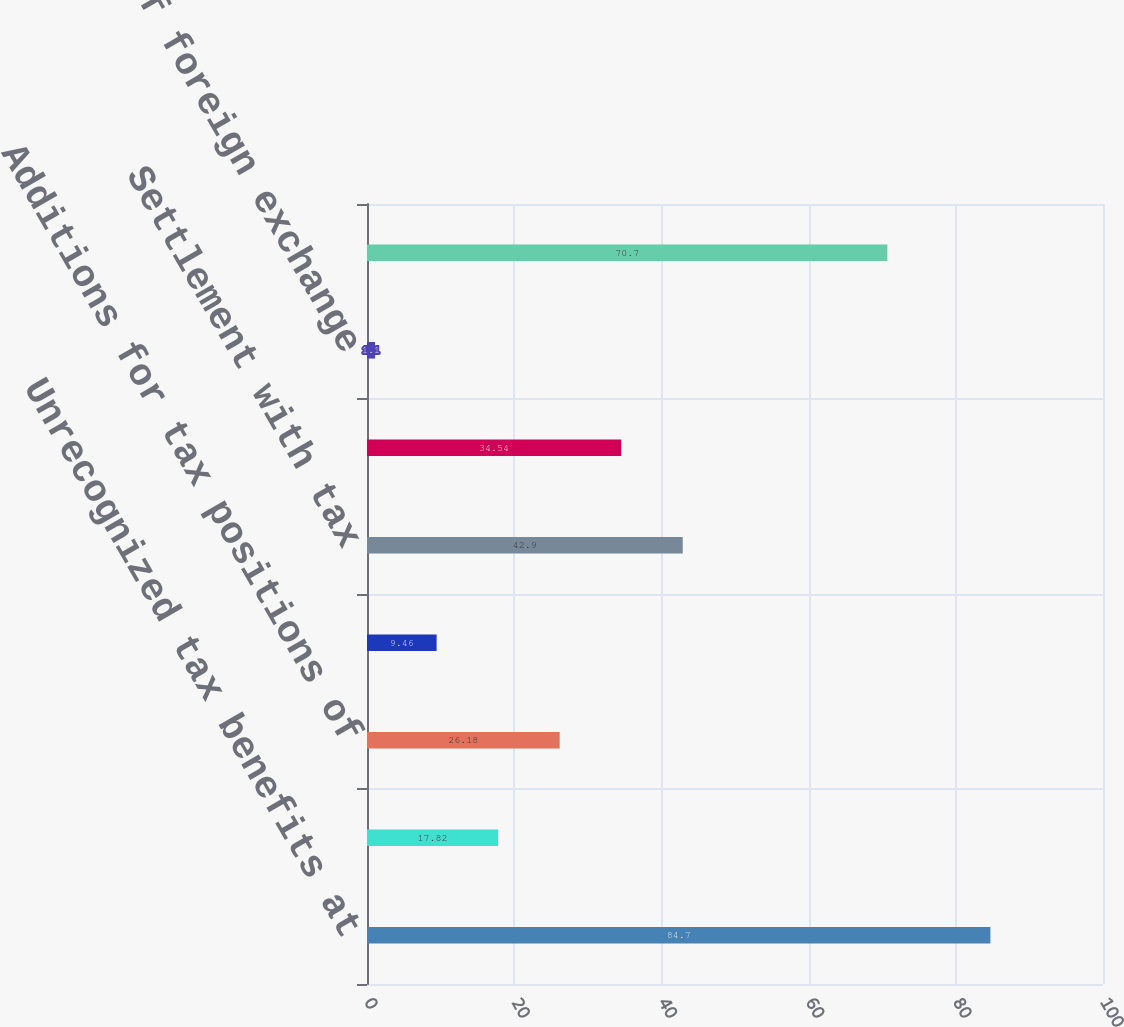Convert chart to OTSL. <chart><loc_0><loc_0><loc_500><loc_500><bar_chart><fcel>Unrecognized tax benefits at<fcel>Additions for tax positions<fcel>Additions for tax positions of<fcel>Reductions for tax positions<fcel>Settlement with tax<fcel>Expiration of the statute of<fcel>Impact of foreign exchange<fcel>Unrecognized tax benefit at<nl><fcel>84.7<fcel>17.82<fcel>26.18<fcel>9.46<fcel>42.9<fcel>34.54<fcel>1.1<fcel>70.7<nl></chart> 